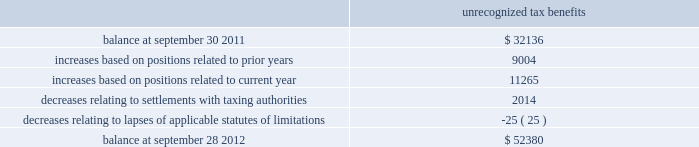Skyworks solutions , inc .
Notes to consolidated financial statements 2014 ( continued ) maintained a valuation allowance of $ 47.0 million .
This valuation allowance is comprised of $ 33.6 million related to u.s .
State tax credits , of which $ 3.6 million are state tax credits acquired from aati in fiscal year 2012 , and $ 13.4 million related to foreign deferred tax assets .
If these benefits are recognized in a future period the valuation allowance on deferred tax assets will be reversed and up to a $ 46.6 million income tax benefit , and up to a $ 0.4 million reduction to goodwill may be recognized .
The company will need to generate $ 209.0 million of future united states federal taxable income to utilize our united states deferred tax assets as of september 28 , 2012 .
Deferred tax assets are recognized for foreign operations when management believes it is more likely than not that the deferred tax assets will be recovered during the carry forward period .
The company will continue to assess its valuation allowance in future periods .
As of september 28 , 2012 , the company has united states federal net operating loss carry forwards of approximately $ 74.3 million , including $ 29.5 million related to the acquisition of sige , which will expire at various dates through 2030 and $ 28.1 million related to the acquisition of aati , which will expire at various dates through 2031 .
The utilization of these net operating losses is subject to certain annual limitations as required under internal revenue code section 382 and similar state income tax provisions .
The company also has united states federal income tax credit carry forwards of $ 37.8 million , of which $ 30.4 million of federal income tax credit carry forwards have not been recorded as a deferred tax asset .
The company also has state income tax credit carry forwards of $ 33.6 million , for which the company has provided a valuation allowance .
The united states federal tax credits expire at various dates through 2032 .
The state tax credits relate primarily to california research tax credits which can be carried forward indefinitely .
The company has continued to expand its operations and increase its investments in numerous international jurisdictions .
These activities will increase the company 2019s earnings attributable to foreign jurisdictions .
As of september 28 , 2012 , no provision has been made for united states federal , state , or additional foreign income taxes related to approximately $ 371.5 million of undistributed earnings of foreign subsidiaries which have been or are intended to be permanently reinvested .
It is not practicable to determine the united states federal income tax liability , if any , which would be payable if such earnings were not permanently reinvested .
The company 2019s gross unrecognized tax benefits totaled $ 52.4 million and $ 32.1 million as of september 28 , 2012 and september 30 , 2011 , respectively .
Of the total unrecognized tax benefits at september 28 , 2012 , $ 38.8 million would impact the effective tax rate , if recognized .
The remaining unrecognized tax benefits would not impact the effective tax rate , if recognized , due to the company 2019s valuation allowance and certain positions which were required to be capitalized .
There are no positions which the company anticipates could change within the next twelve months .
A reconciliation of the beginning and ending amount of gross unrecognized tax benefits is as follows ( in thousands ) : unrecognized tax benefits .
Page 114 annual report .
What is the net chance in unrecognized tax benefits from 2011 to 2012 , ( in millions ) ? 
Computations: (52.4 - 32.1)
Answer: 20.3. 